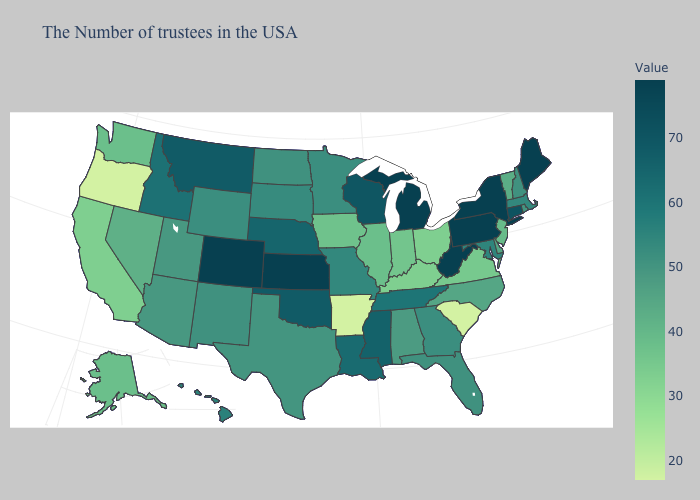Does the map have missing data?
Concise answer only. No. Which states hav the highest value in the South?
Concise answer only. West Virginia. Which states have the lowest value in the MidWest?
Give a very brief answer. Ohio. Among the states that border North Dakota , does South Dakota have the lowest value?
Concise answer only. No. Does Oregon have the lowest value in the West?
Short answer required. Yes. Does Iowa have the highest value in the MidWest?
Keep it brief. No. 